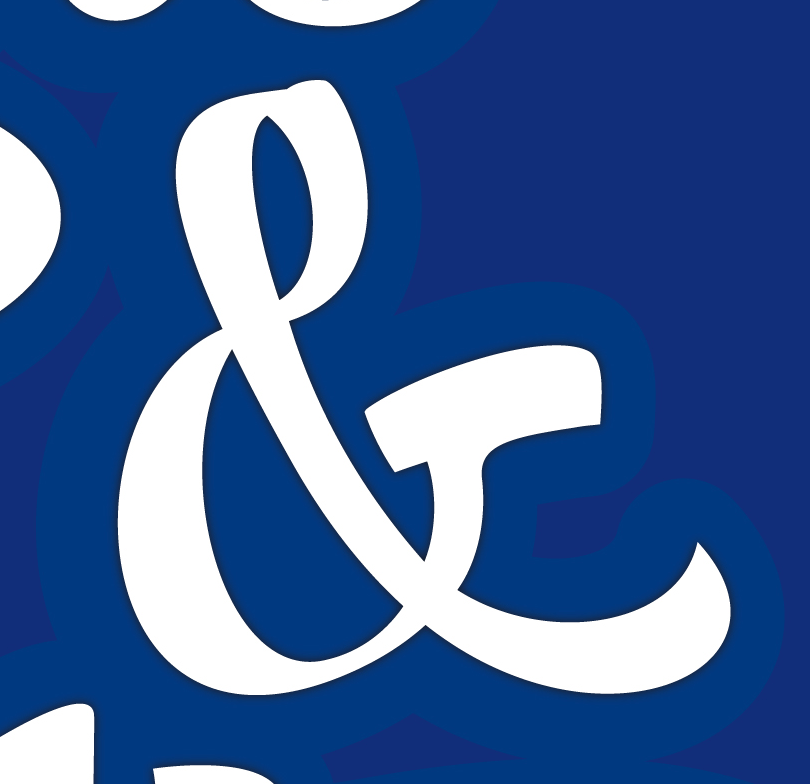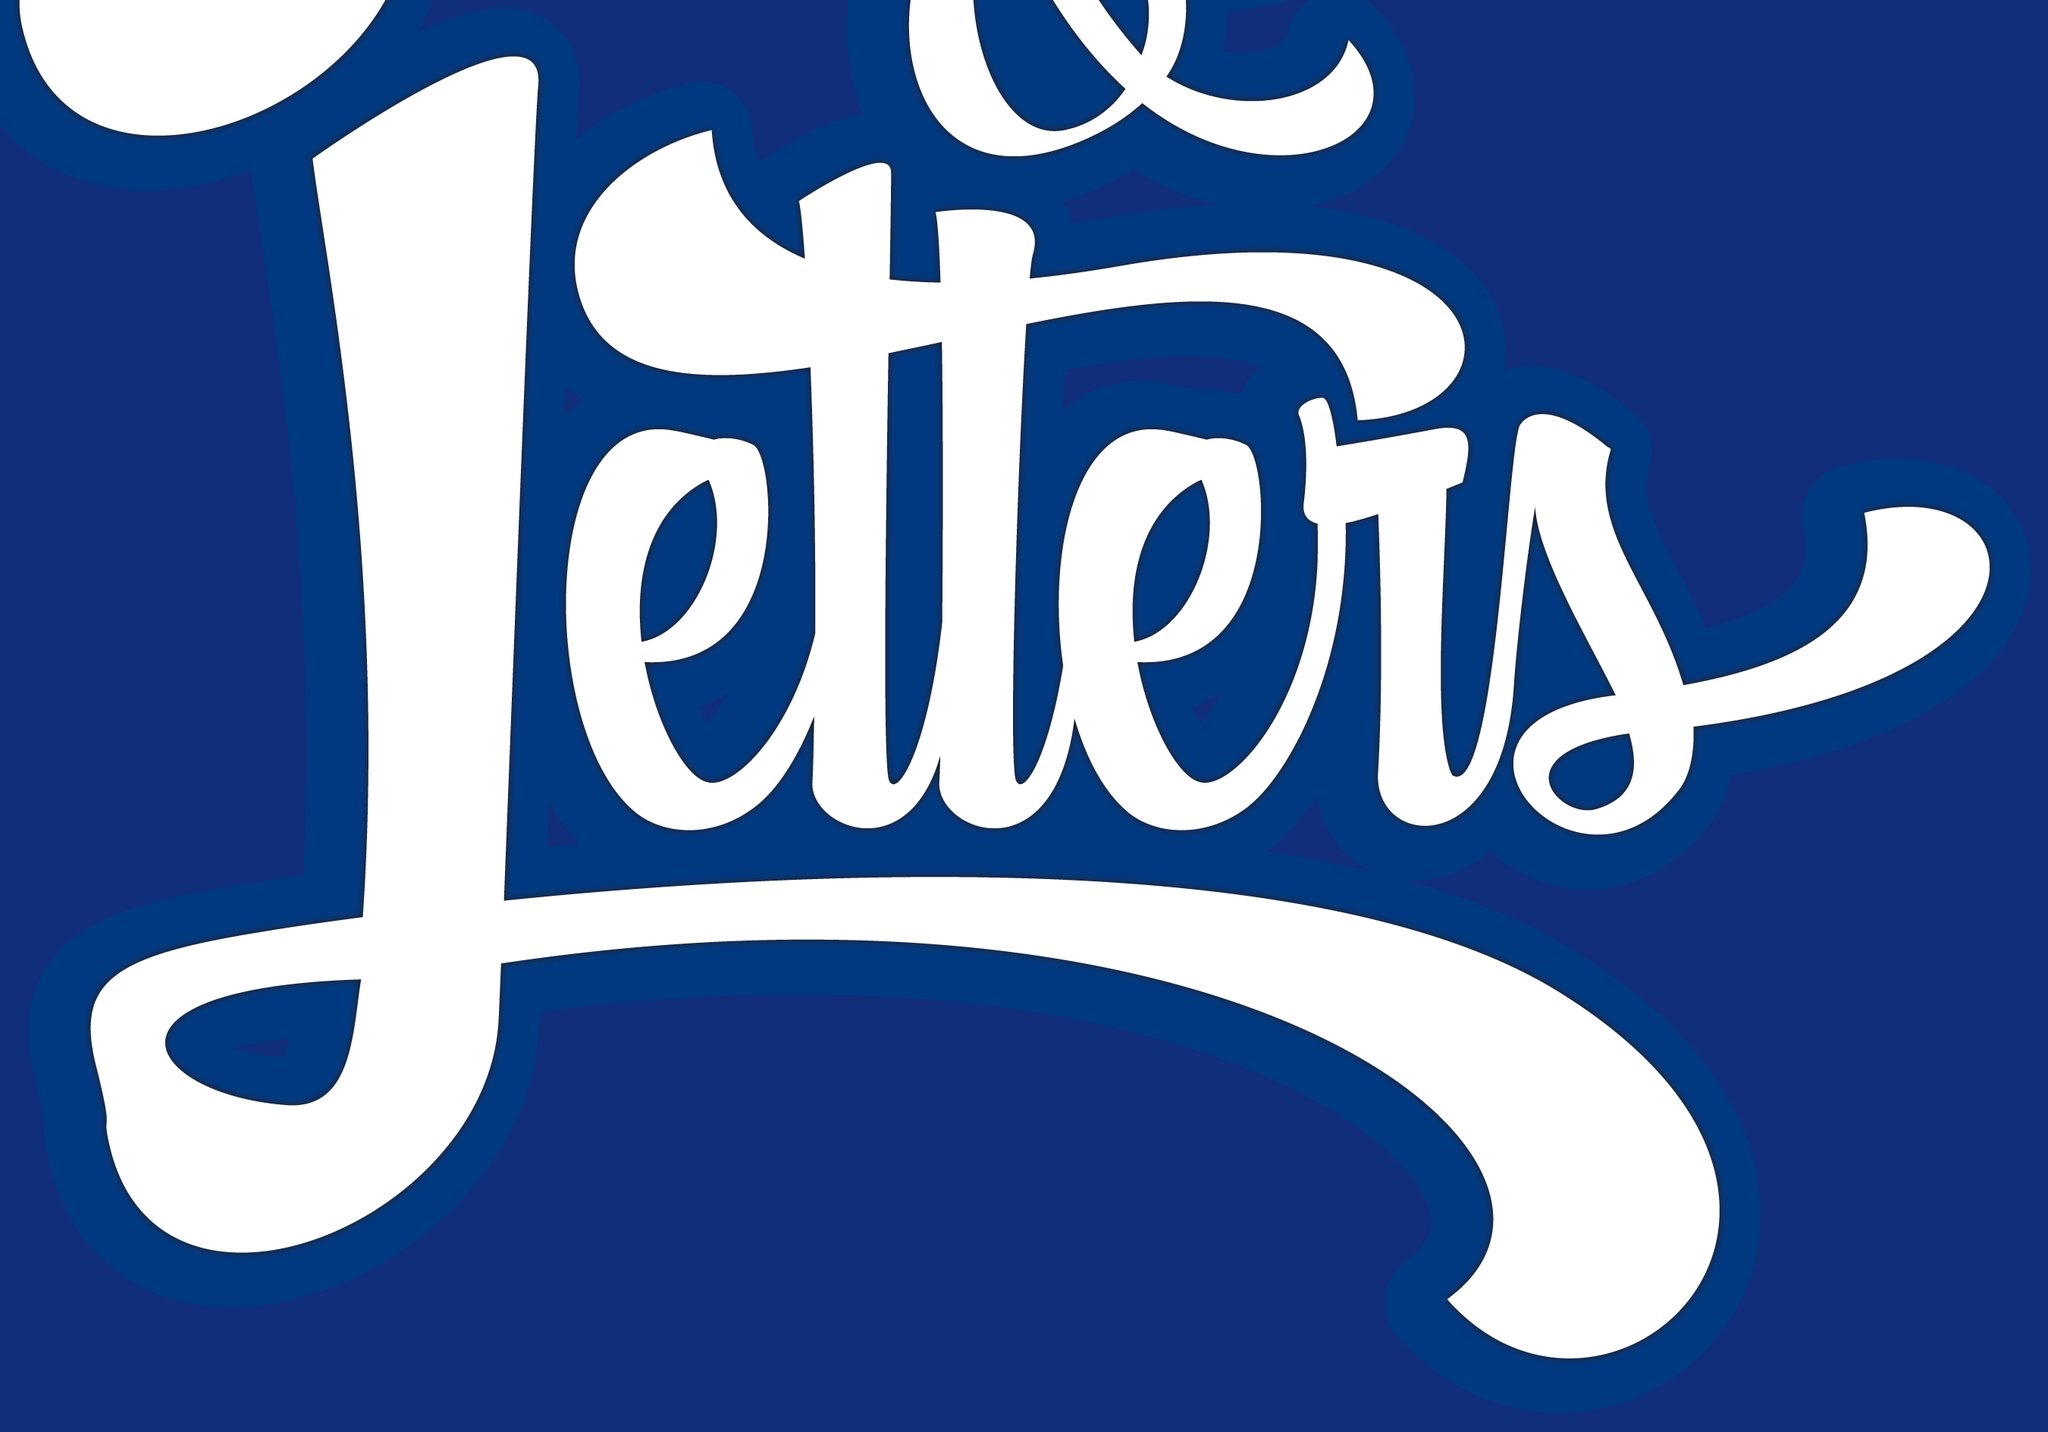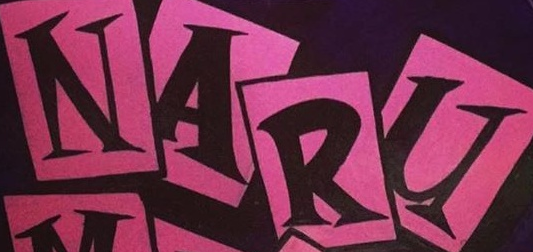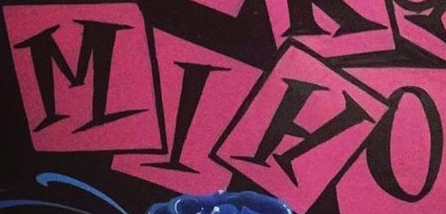What text is displayed in these images sequentially, separated by a semicolon? &; Letters; NARU; MIHO 